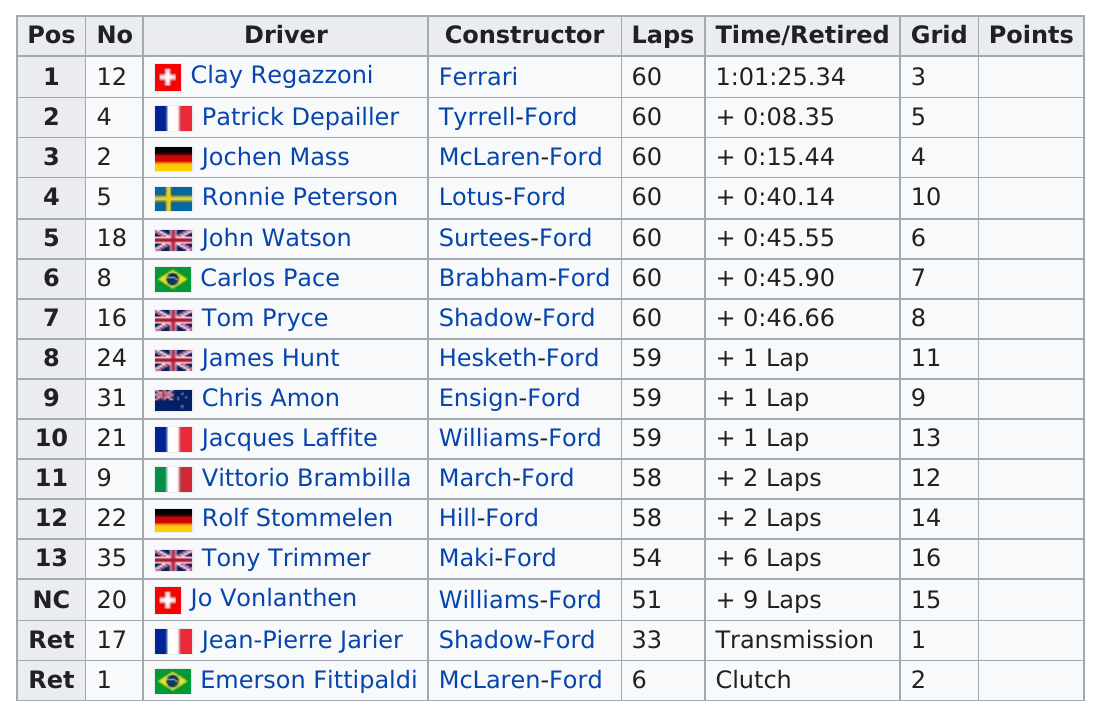Outline some significant characteristics in this image. Jo Vonlanthen was the driver who came in last place, excluding any mechanical failures. In total, 4 drivers competed for Great Britain. The number of McLaren-Ford constructors is two. Four drivers represented Great Britain in a recent event. Jean-Pierre Jarier was the driver who was positioned below Jo vonlanthen in the grid. 